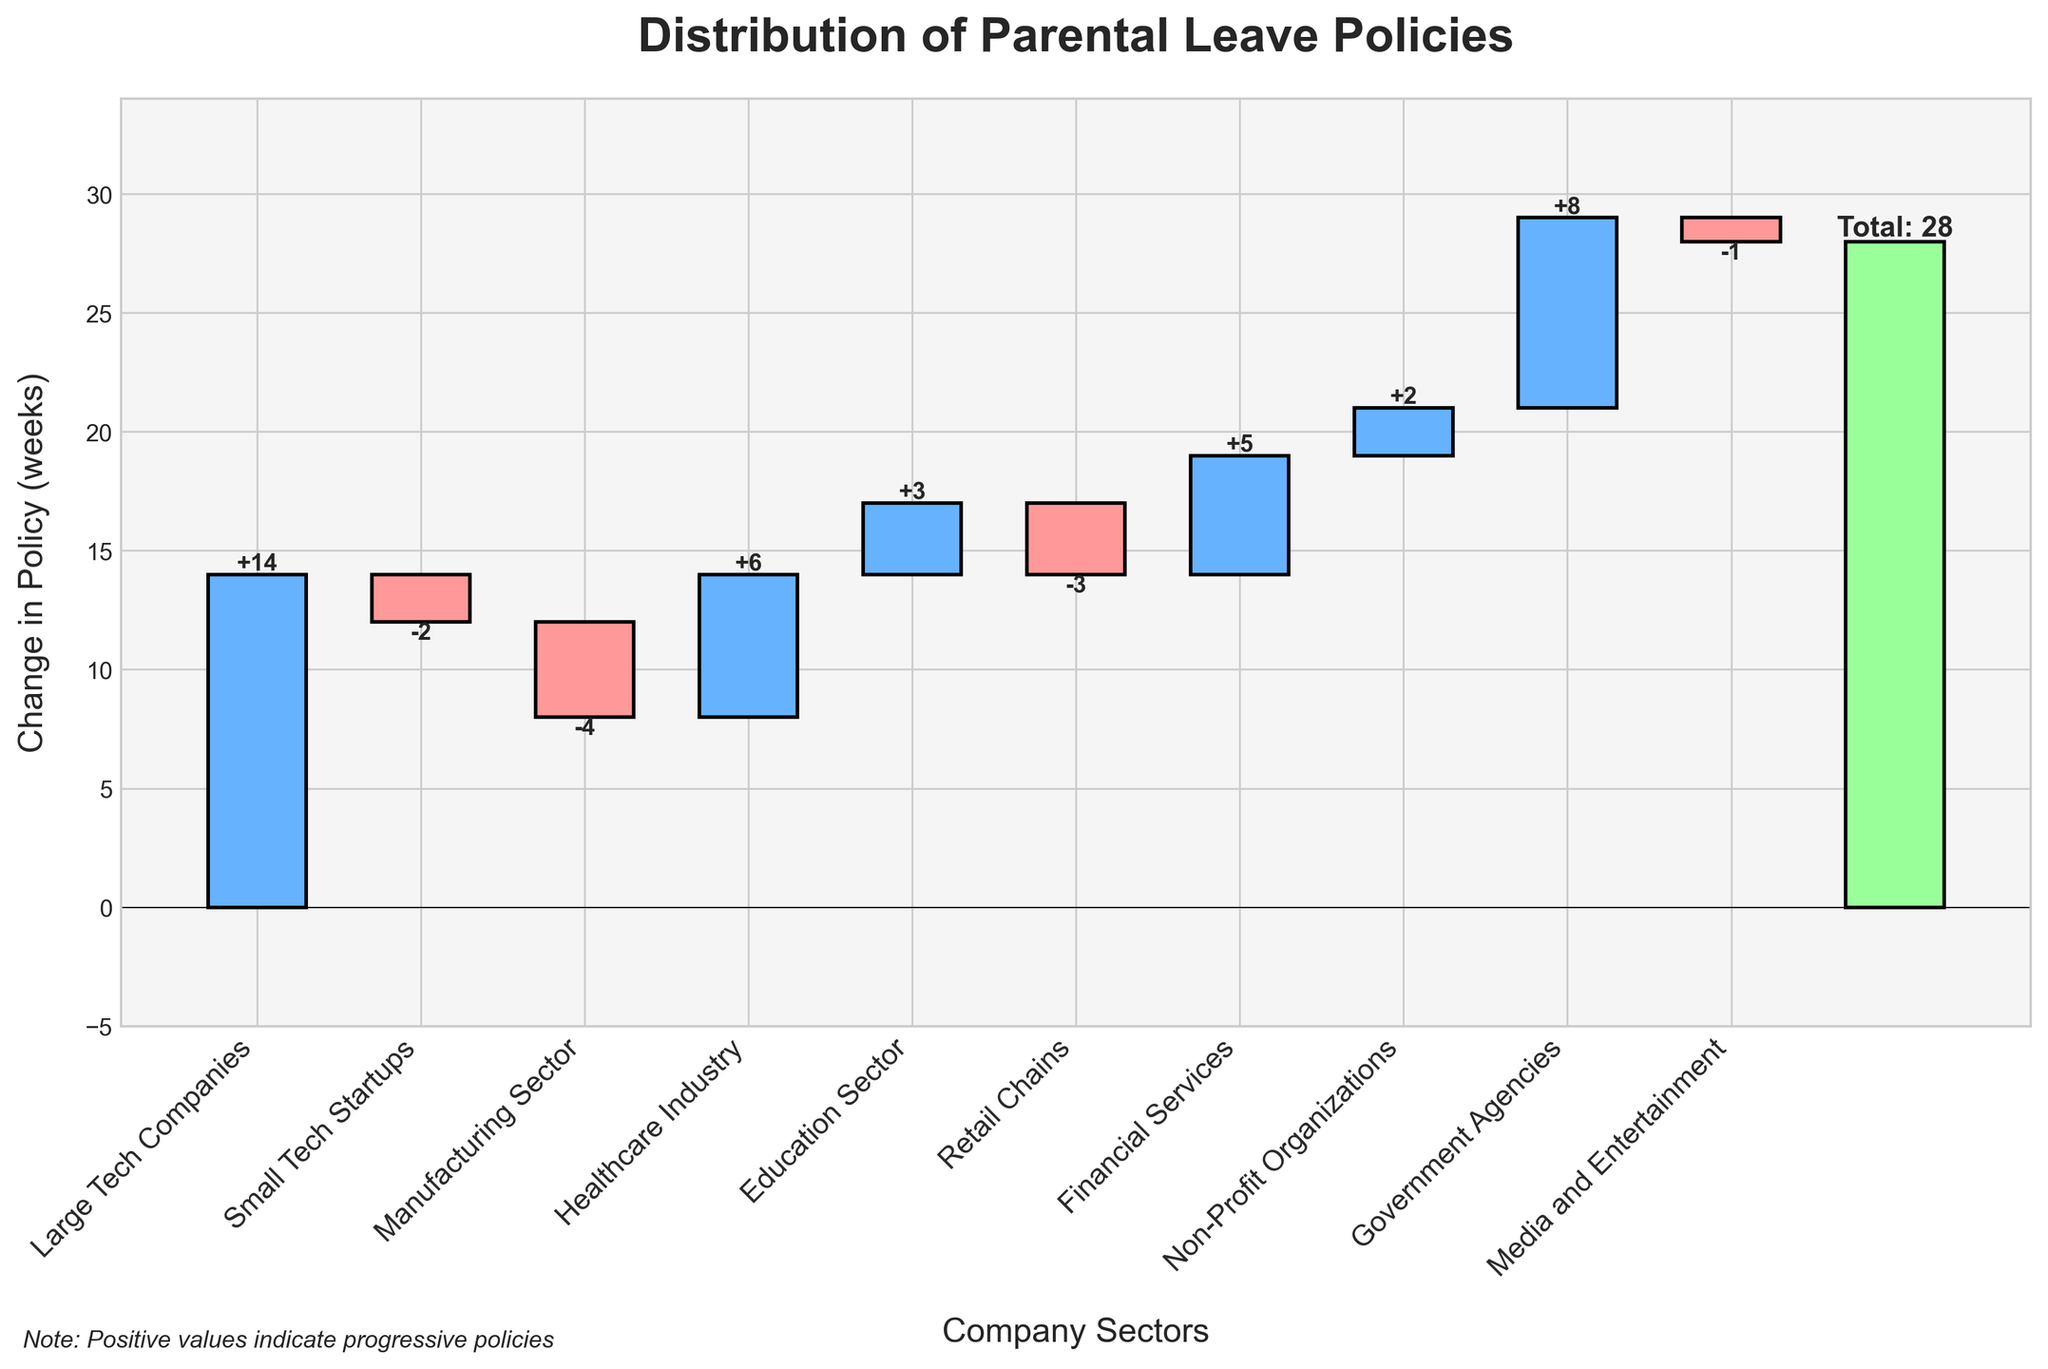What is the total value of the change in parental leave policies? To find the total value, locate the bar labeled 'Total' at the rightmost end of the chart. The value label on top of this bar indicates the total change in policies.
Answer: 28 Which sector has the most significant positive change in parental leave policy? Look at the height and value labels of the bars. The tallest bar with a positive value in the Healthcare Industry indicates the most significant positive change.
Answer: Healthcare Industry How does the parental leave policy change in the Manufacturing Sector compare to that in Retail Chains? Compare the height and value labels of the bars for the Manufacturing Sector and Retail Chains. The Manufacturing Sector has a change of -4 weeks, while Retail Chains have -3 weeks.
Answer: Manufacturing Sector has a more considerable negative change Which sector had the smallest increase in parental leave policy? Identify the smallest positive value among the bars. The Non-Profit Organizations have the smallest positive change with a value of +2 weeks.
Answer: Non-Profit Organizations What is the combined change in parental leave policies for the Healthcare Industry and Financial Services? Add the values of the Healthcare Industry (+6 weeks) and Financial Services (+5 weeks). The combined change is 6 + 5 = 11 weeks.
Answer: 11 weeks How many sectors have shown a negative change in parental leave policies? Count the number of bars that fall below the zero line, indicating a negative value. Sectors with negative changes include Small Tech Startups, Manufacturing Sector, Retail Chains, and Media and Entertainment; there are 4 such sectors.
Answer: 4 What is the net change in parental leave policies for Tech Companies (both Large Tech Companies and Small Tech Startups)? Add the changes for Large Tech Companies (+14 weeks) and Small Tech Startups (-2 weeks). The net change is 14 - 2 = 12 weeks.
Answer: 12 weeks How does the change in parental leave policies in the Education Sector compare with that in Government Agencies? Compare the height and value labels of the bars for the Education Sector and Government Agencies. The Education Sector shows +3 weeks, whereas Government Agencies show +8 weeks.
Answer: Government Agencies have a larger positive change 